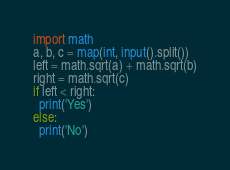Convert code to text. <code><loc_0><loc_0><loc_500><loc_500><_Python_>import math
a, b, c = map(int, input().split())
left = math.sqrt(a) + math.sqrt(b)
right = math.sqrt(c)
if left < right:
  print('Yes')
else: 
  print('No')</code> 